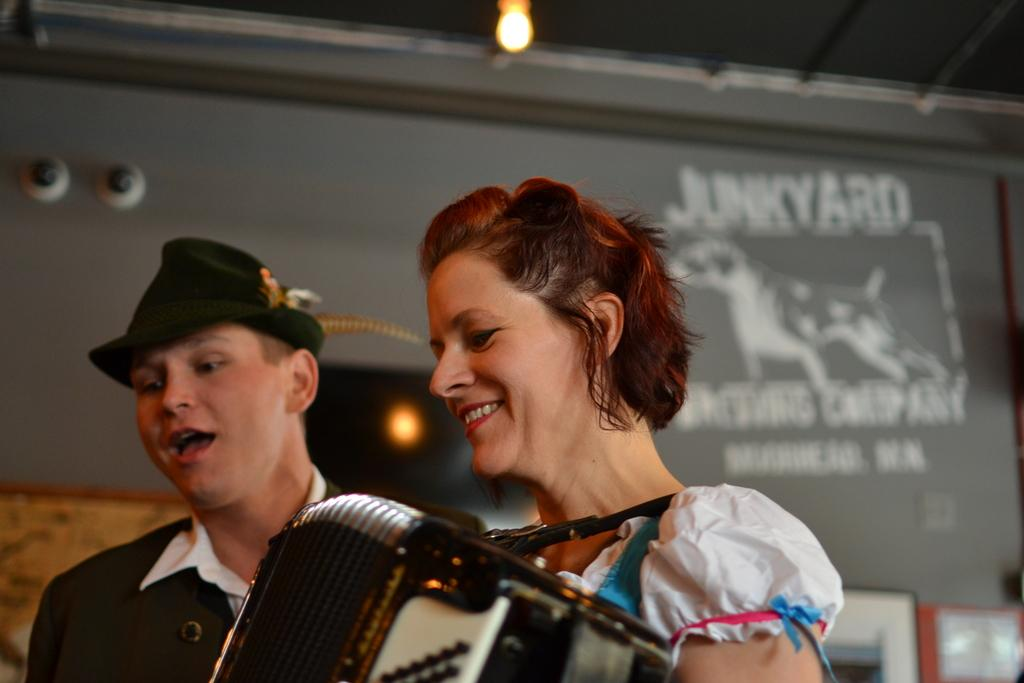How many people are in the image? There are two persons in the image. What are the people doing in the image? One person is playing accordions and concertinas. What can be seen in the background of the image? There are frames attached to the wall in the background of the image. What type of fuel is being used by the company in the image? There is no mention of a company or fuel in the image; it features two people and musical instruments. 